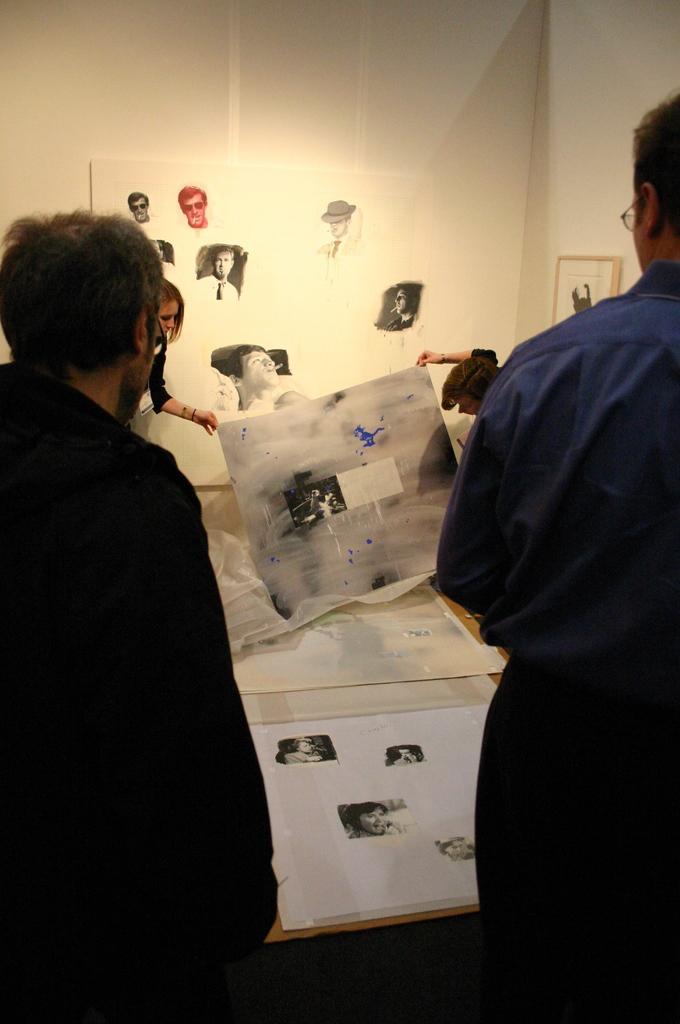Can you describe this image briefly? In this image I can see a person wearing black dress and another person wearing shirt and pant are standing. In front of them I can see few papers on the table. In the background I can see two other persons standing, the wall, a photo frame and few pictures of a person. 